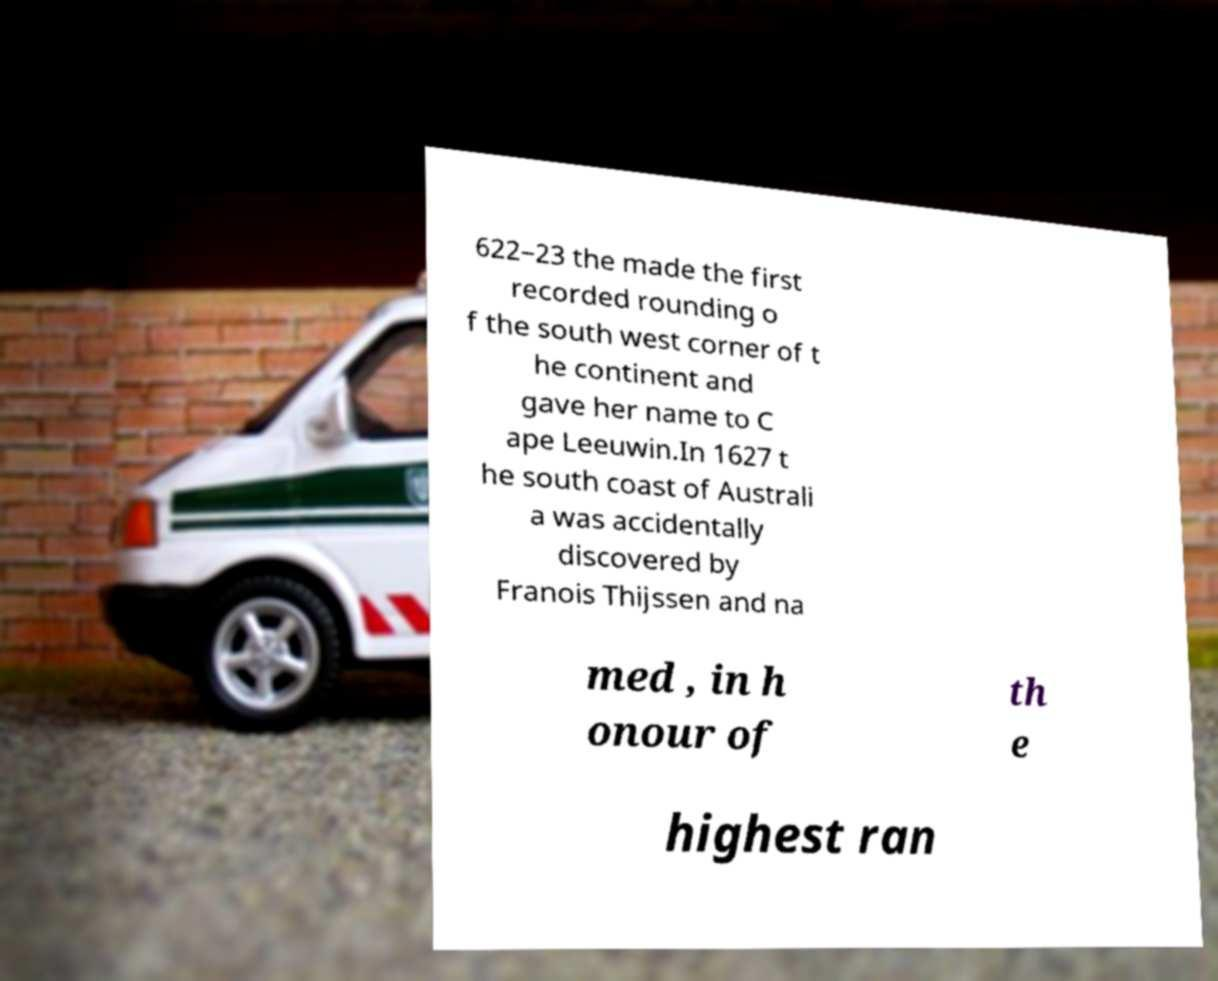Please identify and transcribe the text found in this image. 622–23 the made the first recorded rounding o f the south west corner of t he continent and gave her name to C ape Leeuwin.In 1627 t he south coast of Australi a was accidentally discovered by Franois Thijssen and na med , in h onour of th e highest ran 